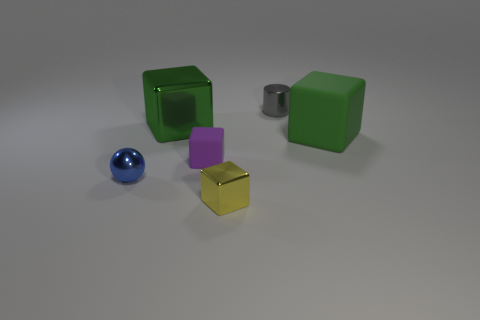How many rubber things are yellow things or big green cubes?
Offer a very short reply. 1. The block that is the same color as the large metal object is what size?
Offer a terse response. Large. The green block that is left of the matte thing on the right side of the tiny purple thing is made of what material?
Offer a very short reply. Metal. How many things are either purple objects or objects that are behind the tiny blue shiny object?
Give a very brief answer. 4. The green block that is made of the same material as the yellow block is what size?
Make the answer very short. Large. What number of red things are tiny rubber objects or matte things?
Give a very brief answer. 0. The rubber thing that is the same color as the big shiny block is what shape?
Make the answer very short. Cube. Do the tiny metallic thing behind the purple matte object and the tiny metallic thing that is to the left of the purple thing have the same shape?
Make the answer very short. No. How many big green metal objects are there?
Ensure brevity in your answer.  1. The yellow object that is made of the same material as the tiny blue sphere is what shape?
Keep it short and to the point. Cube. 